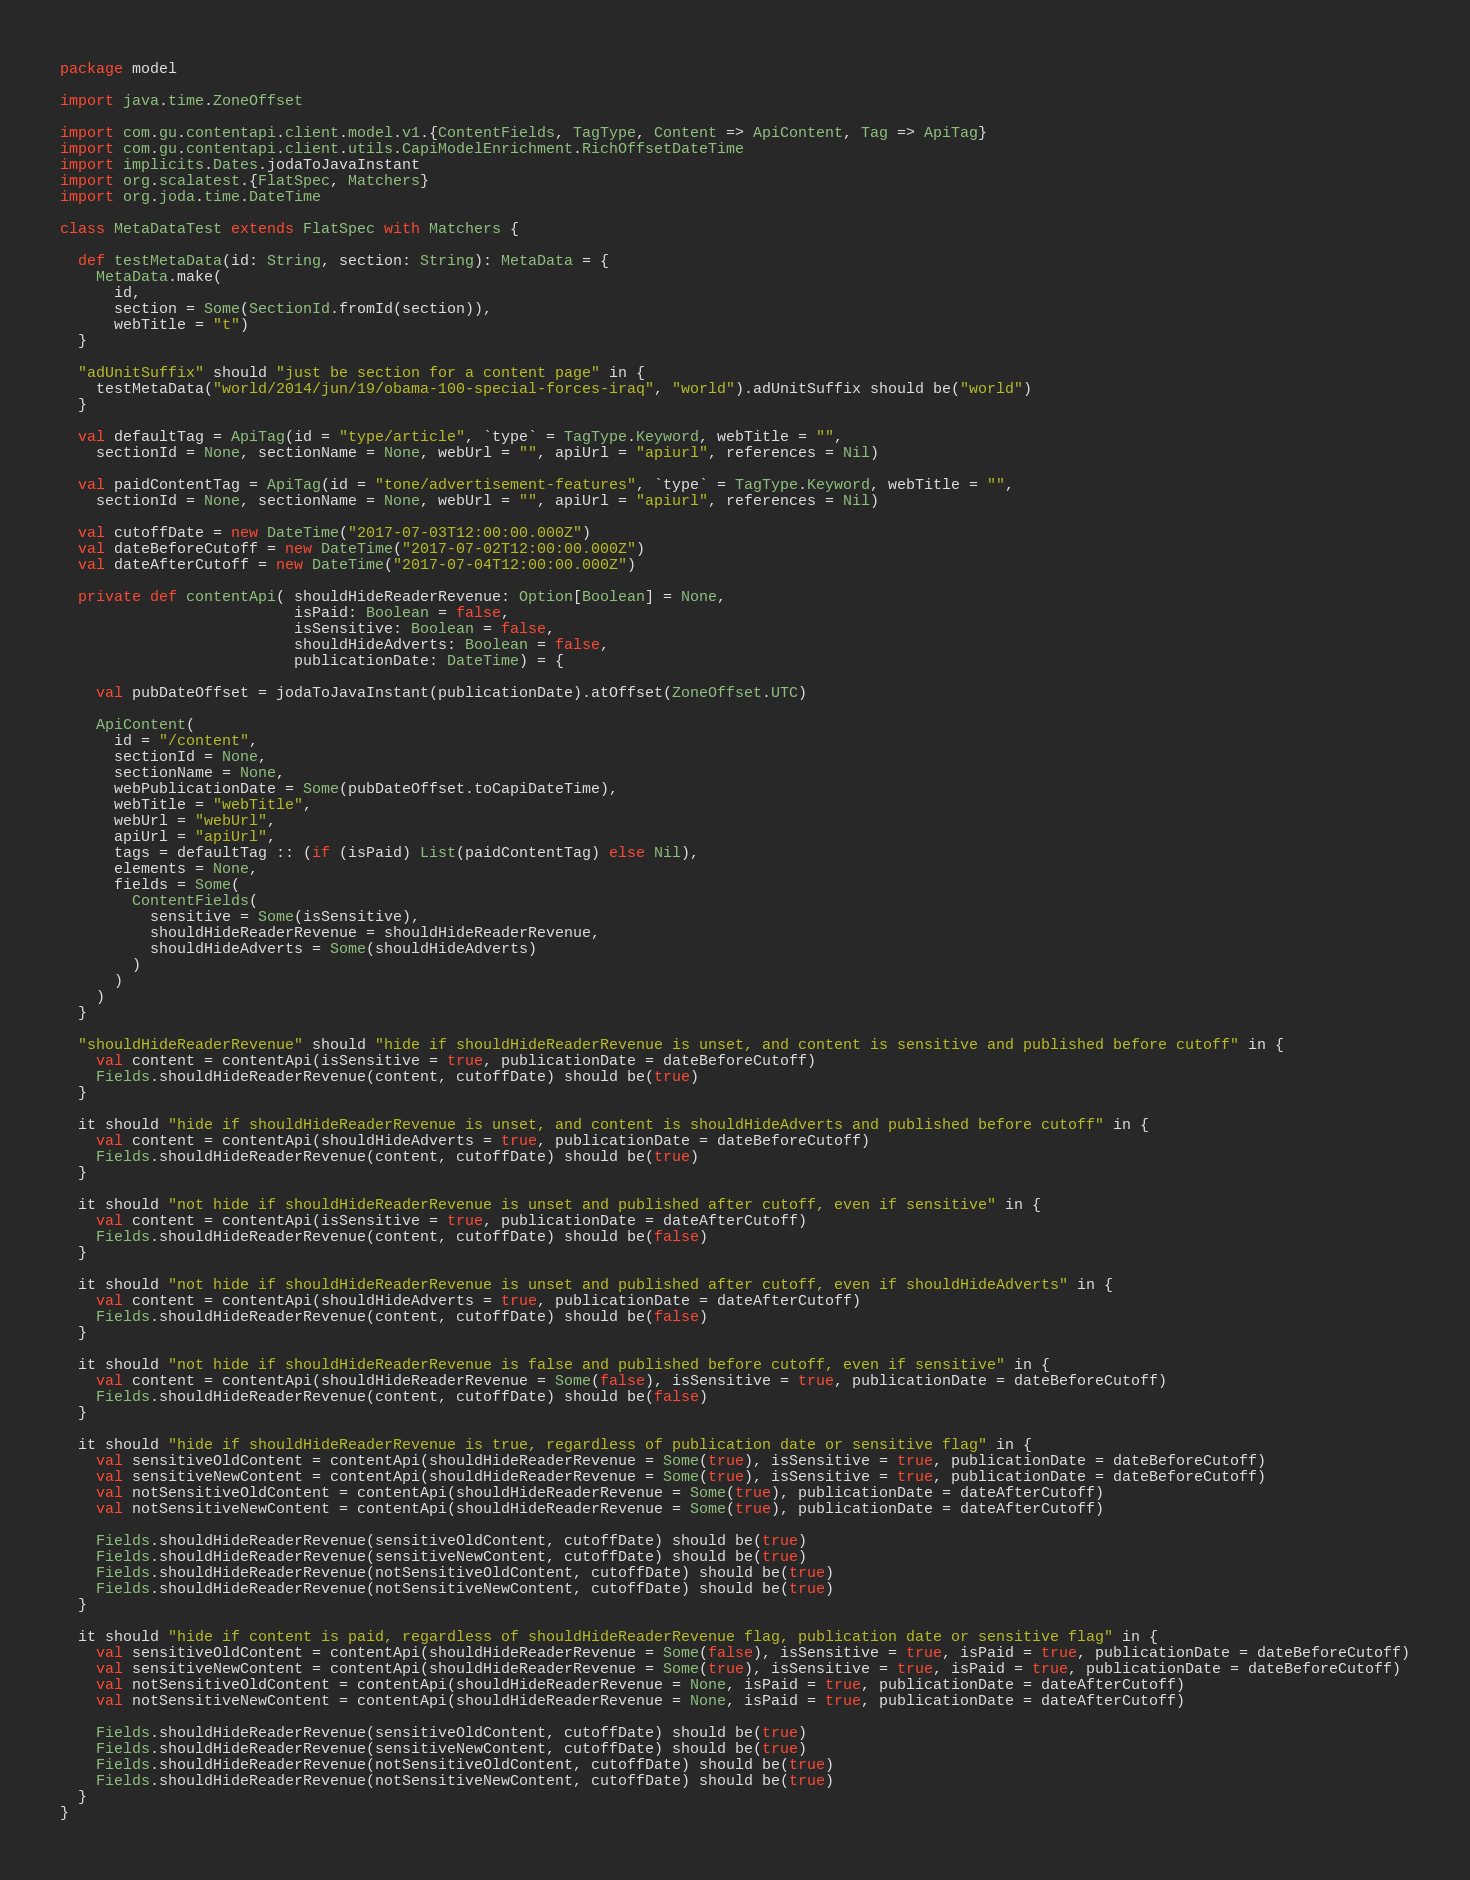Convert code to text. <code><loc_0><loc_0><loc_500><loc_500><_Scala_>package model

import java.time.ZoneOffset

import com.gu.contentapi.client.model.v1.{ContentFields, TagType, Content => ApiContent, Tag => ApiTag}
import com.gu.contentapi.client.utils.CapiModelEnrichment.RichOffsetDateTime
import implicits.Dates.jodaToJavaInstant
import org.scalatest.{FlatSpec, Matchers}
import org.joda.time.DateTime

class MetaDataTest extends FlatSpec with Matchers {

  def testMetaData(id: String, section: String): MetaData = {
    MetaData.make(
      id,
      section = Some(SectionId.fromId(section)),
      webTitle = "t")
  }

  "adUnitSuffix" should "just be section for a content page" in {
    testMetaData("world/2014/jun/19/obama-100-special-forces-iraq", "world").adUnitSuffix should be("world")
  }

  val defaultTag = ApiTag(id = "type/article", `type` = TagType.Keyword, webTitle = "",
    sectionId = None, sectionName = None, webUrl = "", apiUrl = "apiurl", references = Nil)

  val paidContentTag = ApiTag(id = "tone/advertisement-features", `type` = TagType.Keyword, webTitle = "",
    sectionId = None, sectionName = None, webUrl = "", apiUrl = "apiurl", references = Nil)

  val cutoffDate = new DateTime("2017-07-03T12:00:00.000Z")
  val dateBeforeCutoff = new DateTime("2017-07-02T12:00:00.000Z")
  val dateAfterCutoff = new DateTime("2017-07-04T12:00:00.000Z")

  private def contentApi( shouldHideReaderRevenue: Option[Boolean] = None,
                          isPaid: Boolean = false,
                          isSensitive: Boolean = false,
                          shouldHideAdverts: Boolean = false,
                          publicationDate: DateTime) = {

    val pubDateOffset = jodaToJavaInstant(publicationDate).atOffset(ZoneOffset.UTC)

    ApiContent(
      id = "/content",
      sectionId = None,
      sectionName = None,
      webPublicationDate = Some(pubDateOffset.toCapiDateTime),
      webTitle = "webTitle",
      webUrl = "webUrl",
      apiUrl = "apiUrl",
      tags = defaultTag :: (if (isPaid) List(paidContentTag) else Nil),
      elements = None,
      fields = Some(
        ContentFields(
          sensitive = Some(isSensitive),
          shouldHideReaderRevenue = shouldHideReaderRevenue,
          shouldHideAdverts = Some(shouldHideAdverts)
        )
      )
    )
  }

  "shouldHideReaderRevenue" should "hide if shouldHideReaderRevenue is unset, and content is sensitive and published before cutoff" in {
    val content = contentApi(isSensitive = true, publicationDate = dateBeforeCutoff)
    Fields.shouldHideReaderRevenue(content, cutoffDate) should be(true)
  }

  it should "hide if shouldHideReaderRevenue is unset, and content is shouldHideAdverts and published before cutoff" in {
    val content = contentApi(shouldHideAdverts = true, publicationDate = dateBeforeCutoff)
    Fields.shouldHideReaderRevenue(content, cutoffDate) should be(true)
  }

  it should "not hide if shouldHideReaderRevenue is unset and published after cutoff, even if sensitive" in {
    val content = contentApi(isSensitive = true, publicationDate = dateAfterCutoff)
    Fields.shouldHideReaderRevenue(content, cutoffDate) should be(false)
  }

  it should "not hide if shouldHideReaderRevenue is unset and published after cutoff, even if shouldHideAdverts" in {
    val content = contentApi(shouldHideAdverts = true, publicationDate = dateAfterCutoff)
    Fields.shouldHideReaderRevenue(content, cutoffDate) should be(false)
  }

  it should "not hide if shouldHideReaderRevenue is false and published before cutoff, even if sensitive" in {
    val content = contentApi(shouldHideReaderRevenue = Some(false), isSensitive = true, publicationDate = dateBeforeCutoff)
    Fields.shouldHideReaderRevenue(content, cutoffDate) should be(false)
  }

  it should "hide if shouldHideReaderRevenue is true, regardless of publication date or sensitive flag" in {
    val sensitiveOldContent = contentApi(shouldHideReaderRevenue = Some(true), isSensitive = true, publicationDate = dateBeforeCutoff)
    val sensitiveNewContent = contentApi(shouldHideReaderRevenue = Some(true), isSensitive = true, publicationDate = dateBeforeCutoff)
    val notSensitiveOldContent = contentApi(shouldHideReaderRevenue = Some(true), publicationDate = dateAfterCutoff)
    val notSensitiveNewContent = contentApi(shouldHideReaderRevenue = Some(true), publicationDate = dateAfterCutoff)

    Fields.shouldHideReaderRevenue(sensitiveOldContent, cutoffDate) should be(true)
    Fields.shouldHideReaderRevenue(sensitiveNewContent, cutoffDate) should be(true)
    Fields.shouldHideReaderRevenue(notSensitiveOldContent, cutoffDate) should be(true)
    Fields.shouldHideReaderRevenue(notSensitiveNewContent, cutoffDate) should be(true)
  }

  it should "hide if content is paid, regardless of shouldHideReaderRevenue flag, publication date or sensitive flag" in {
    val sensitiveOldContent = contentApi(shouldHideReaderRevenue = Some(false), isSensitive = true, isPaid = true, publicationDate = dateBeforeCutoff)
    val sensitiveNewContent = contentApi(shouldHideReaderRevenue = Some(true), isSensitive = true, isPaid = true, publicationDate = dateBeforeCutoff)
    val notSensitiveOldContent = contentApi(shouldHideReaderRevenue = None, isPaid = true, publicationDate = dateAfterCutoff)
    val notSensitiveNewContent = contentApi(shouldHideReaderRevenue = None, isPaid = true, publicationDate = dateAfterCutoff)

    Fields.shouldHideReaderRevenue(sensitiveOldContent, cutoffDate) should be(true)
    Fields.shouldHideReaderRevenue(sensitiveNewContent, cutoffDate) should be(true)
    Fields.shouldHideReaderRevenue(notSensitiveOldContent, cutoffDate) should be(true)
    Fields.shouldHideReaderRevenue(notSensitiveNewContent, cutoffDate) should be(true)
  }
}
</code> 